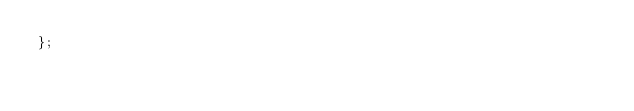<code> <loc_0><loc_0><loc_500><loc_500><_C++_>};

</code> 